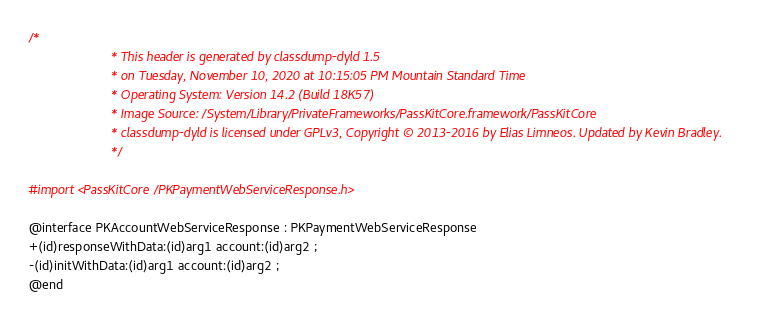<code> <loc_0><loc_0><loc_500><loc_500><_C_>/*
                       * This header is generated by classdump-dyld 1.5
                       * on Tuesday, November 10, 2020 at 10:15:05 PM Mountain Standard Time
                       * Operating System: Version 14.2 (Build 18K57)
                       * Image Source: /System/Library/PrivateFrameworks/PassKitCore.framework/PassKitCore
                       * classdump-dyld is licensed under GPLv3, Copyright © 2013-2016 by Elias Limneos. Updated by Kevin Bradley.
                       */

#import <PassKitCore/PKPaymentWebServiceResponse.h>

@interface PKAccountWebServiceResponse : PKPaymentWebServiceResponse
+(id)responseWithData:(id)arg1 account:(id)arg2 ;
-(id)initWithData:(id)arg1 account:(id)arg2 ;
@end

</code> 